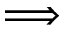<formula> <loc_0><loc_0><loc_500><loc_500>\Longrightarrow</formula> 